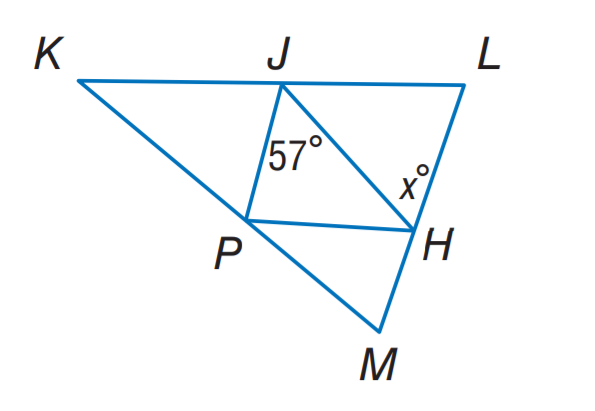Answer the mathemtical geometry problem and directly provide the correct option letter.
Question: J H, J P, and P H are midsegments of \triangle K L M. Find x.
Choices: A: 37 B: 47 C: 57 D: 67 C 